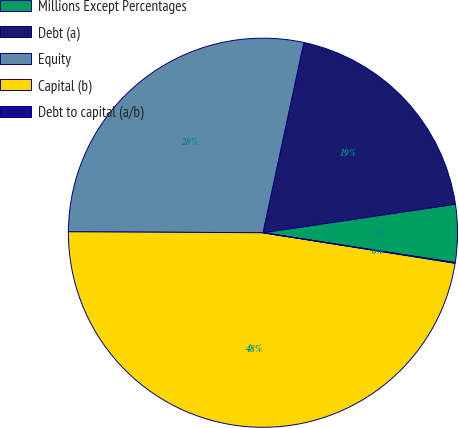<chart> <loc_0><loc_0><loc_500><loc_500><pie_chart><fcel>Millions Except Percentages<fcel>Debt (a)<fcel>Equity<fcel>Capital (b)<fcel>Debt to capital (a/b)<nl><fcel>4.8%<fcel>19.29%<fcel>28.29%<fcel>47.58%<fcel>0.05%<nl></chart> 